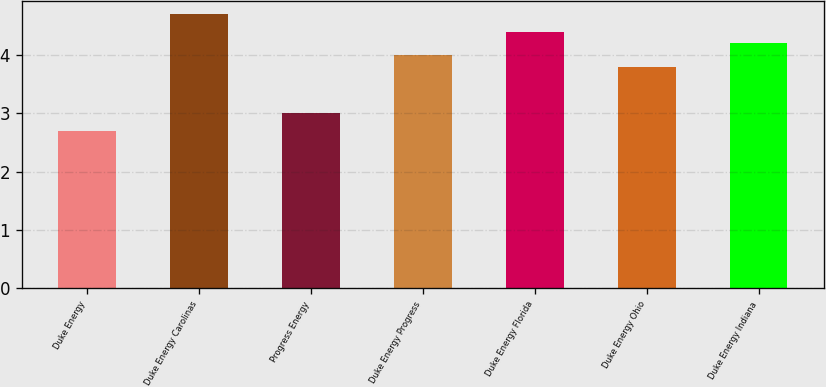Convert chart. <chart><loc_0><loc_0><loc_500><loc_500><bar_chart><fcel>Duke Energy<fcel>Duke Energy Carolinas<fcel>Progress Energy<fcel>Duke Energy Progress<fcel>Duke Energy Florida<fcel>Duke Energy Ohio<fcel>Duke Energy Indiana<nl><fcel>2.7<fcel>4.7<fcel>3<fcel>4<fcel>4.4<fcel>3.8<fcel>4.2<nl></chart> 